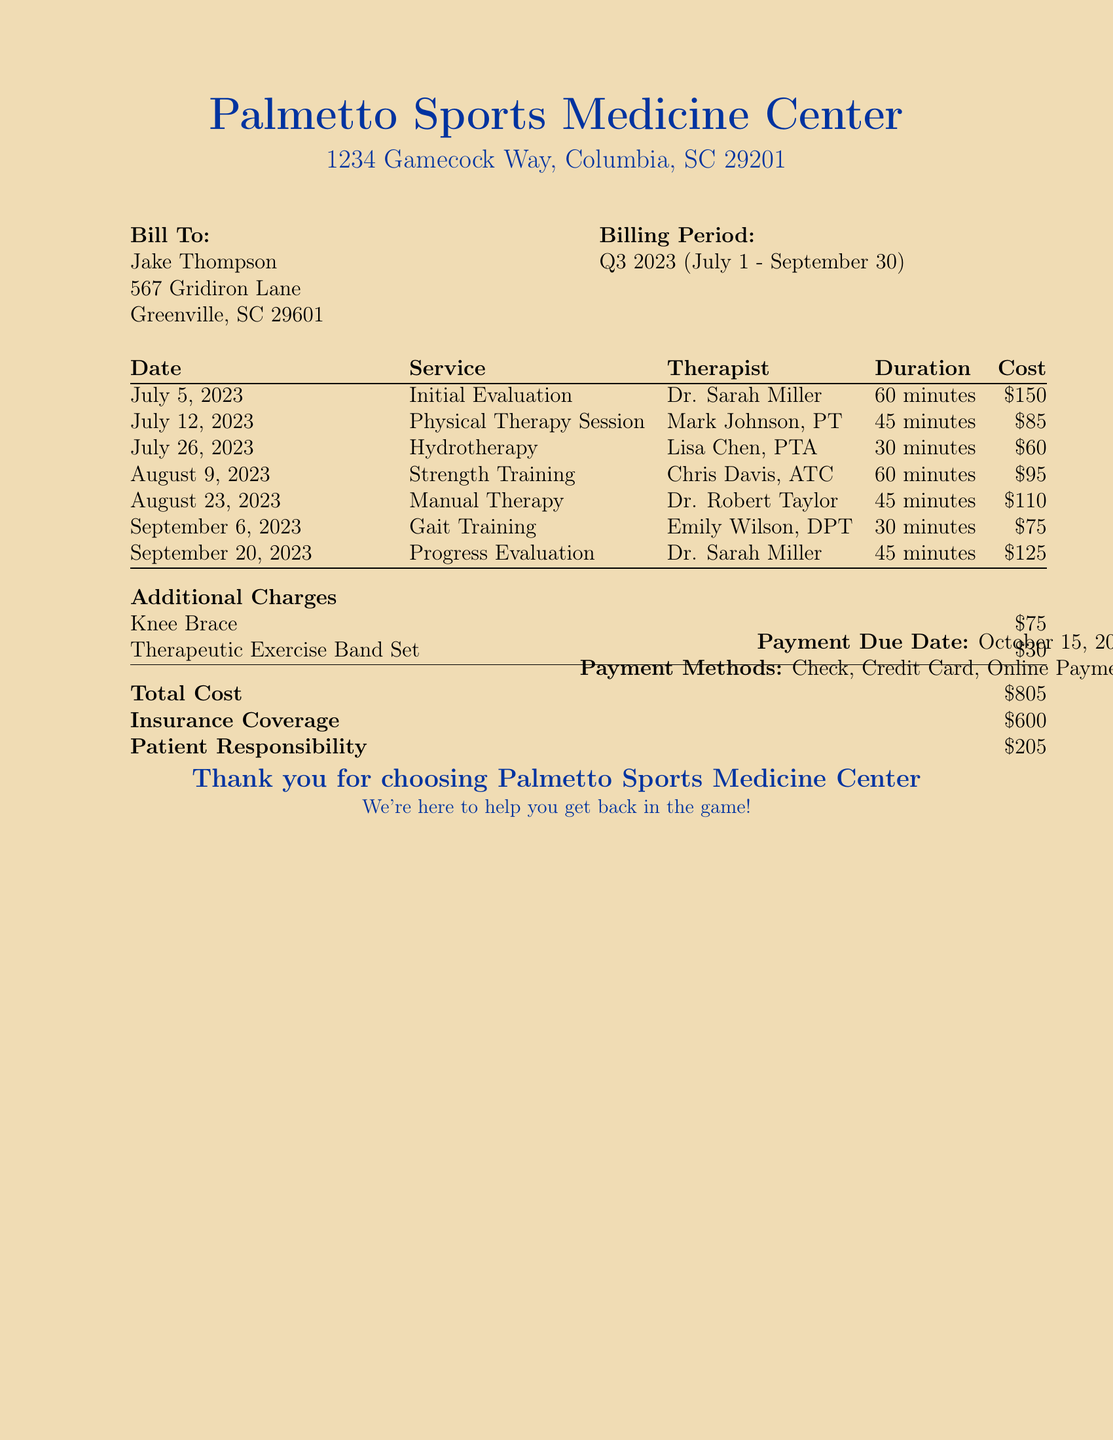What is the total cost? The total cost is the sum of treatment sessions and additional charges listed in the document.
Answer: $805 Who provided the initial evaluation? The document specifically states that the initial evaluation was conducted by Dr. Sarah Miller.
Answer: Dr. Sarah Miller How many physical therapy sessions are listed? The document includes one physical therapy session on July 12, 2023.
Answer: 1 What is the duration of the manual therapy session? The duration for the manual therapy session is mentioned as 45 minutes in the document.
Answer: 45 minutes What was the insurance coverage amount? The document clearly states the insurance coverage amount is $600.
Answer: $600 What is the patient responsibility? The patient responsibility is calculated as the total cost minus the insurance coverage amount shown in the document.
Answer: $205 When is the payment due date? The document specifies the payment due date as October 15, 2023.
Answer: October 15, 2023 What method of payment is accepted? The document lists check, credit card, and online payment as accepted payment methods.
Answer: Check, Credit Card, Online Payment Which type of therapy session had the highest cost? Based on the treatment session costs reflected in the document, the initial evaluation session is the highest at $150.
Answer: Initial Evaluation 